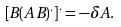Convert formula to latex. <formula><loc_0><loc_0><loc_500><loc_500>\left [ B ( A \, B ) ^ { . } \right ] ^ { . } = - \delta A .</formula> 